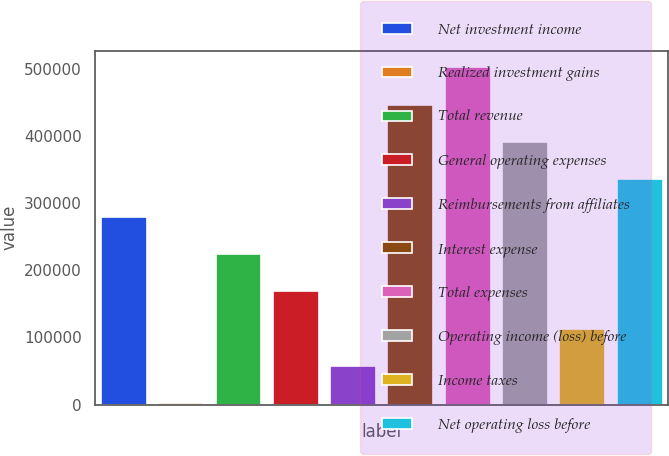<chart> <loc_0><loc_0><loc_500><loc_500><bar_chart><fcel>Net investment income<fcel>Realized investment gains<fcel>Total revenue<fcel>General operating expenses<fcel>Reimbursements from affiliates<fcel>Interest expense<fcel>Total expenses<fcel>Operating income (loss) before<fcel>Income taxes<fcel>Net operating loss before<nl><fcel>279469<fcel>1646<fcel>223904<fcel>168340<fcel>57210.6<fcel>446163<fcel>501727<fcel>390598<fcel>112775<fcel>335034<nl></chart> 